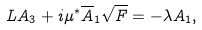<formula> <loc_0><loc_0><loc_500><loc_500>L A _ { 3 } + i \mu ^ { \ast } \overline { A } _ { 1 } \sqrt { F } = - \lambda A _ { 1 } ,</formula> 